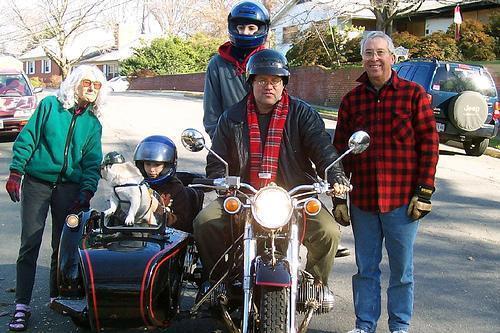How many people?
Give a very brief answer. 5. How many animals?
Give a very brief answer. 1. How many people wearing glasses?
Give a very brief answer. 3. How many dogs are in the picture?
Give a very brief answer. 1. How many people can you see?
Give a very brief answer. 5. How many cars are there?
Give a very brief answer. 2. 